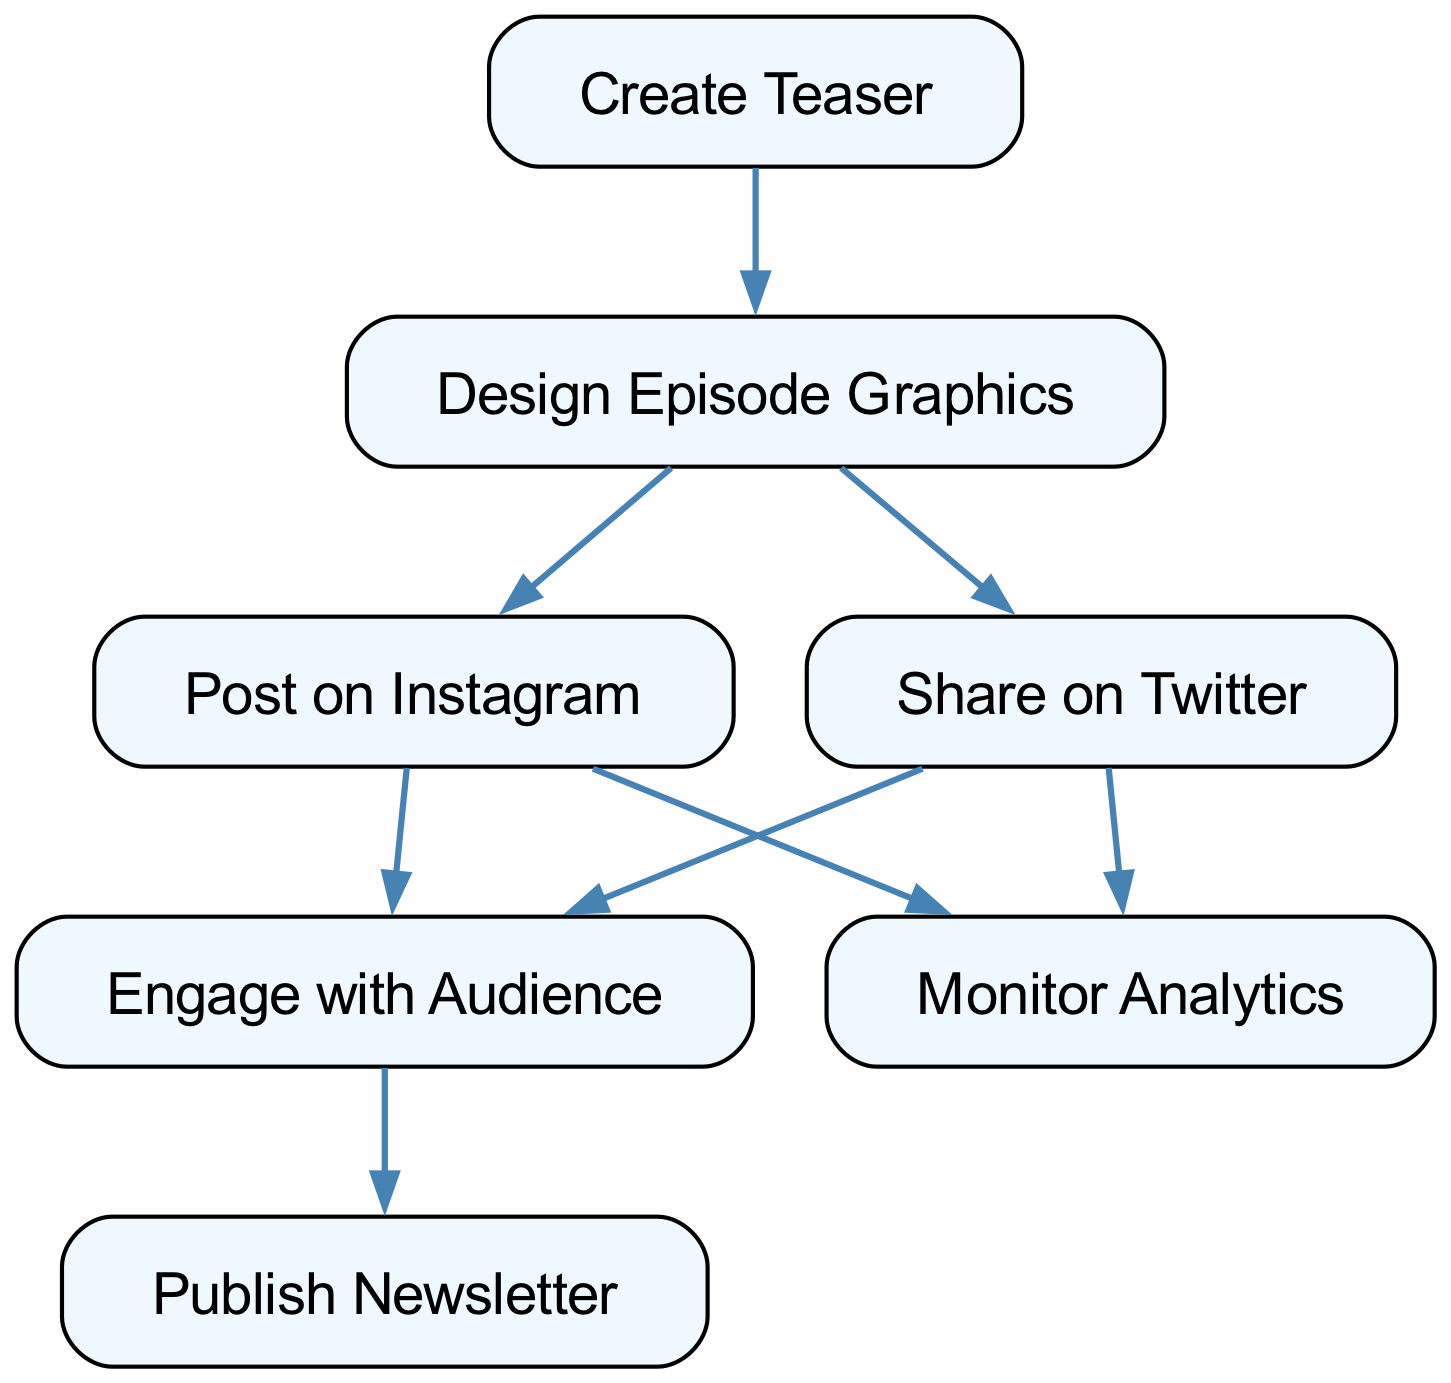What is the first step in the social media promotion strategy? The first step in the directed graph is represented by the node labeled "Create Teaser". This is the initial action that leads to other activities within the strategy.
Answer: Create Teaser How many nodes are present in the diagram? The diagram includes seven nodes, each representing a specific task in the social media promotion strategy. These nodes are clearly defined in the data provided.
Answer: Seven Which node follows "Design Graphics" directly? In the directed graph, "Design Graphics" leads directly to "Post on Instagram" and "Share on Twitter", indicating these actions follow the design phase.
Answer: Post on Instagram, Share on Twitter What are the two social media platforms mentioned in the strategy? The diagram includes "Post on Instagram" and "Share on Twitter", which are the two platforms explicitly stated for promotional posts.
Answer: Instagram, Twitter What is the relationship between "Engage with Audience" and "Publish Newsletter"? The directed graph shows that engaging with the audience is a precursor to publishing the newsletter; this indicates that effective engagement leads to newsletter creation.
Answer: Engage with Audience leads to Publish Newsletter How many actions lead to "Engage with Audience"? There are two actions that lead to "Engage with Audience", namely from "Post on Instagram" and "Share on Twitter". This indicates both social media actions encourage audience interaction.
Answer: Two What is a common endpoint for both "Post on Instagram" and "Share on Twitter"? Both "Post on Instagram" and "Share on Twitter" direct towards "Monitor Analytics", showing that after using these platforms, the next step involves analyzing performance.
Answer: Monitor Analytics What cumulative effect does engaging with the audience have in this strategy? Engaging with the audience initiates the action of "Publish Newsletter", indicating that audience interaction is crucial for generating newsletter content.
Answer: Publish Newsletter Which task directly precedes "Monitor Analytics"? Both "Post on Instagram" and "Share on Twitter" directly precede "Monitor Analytics" in the flow of the promotion strategy, indicating that analytics monitoring happens after posting.
Answer: Post on Instagram, Share on Twitter 